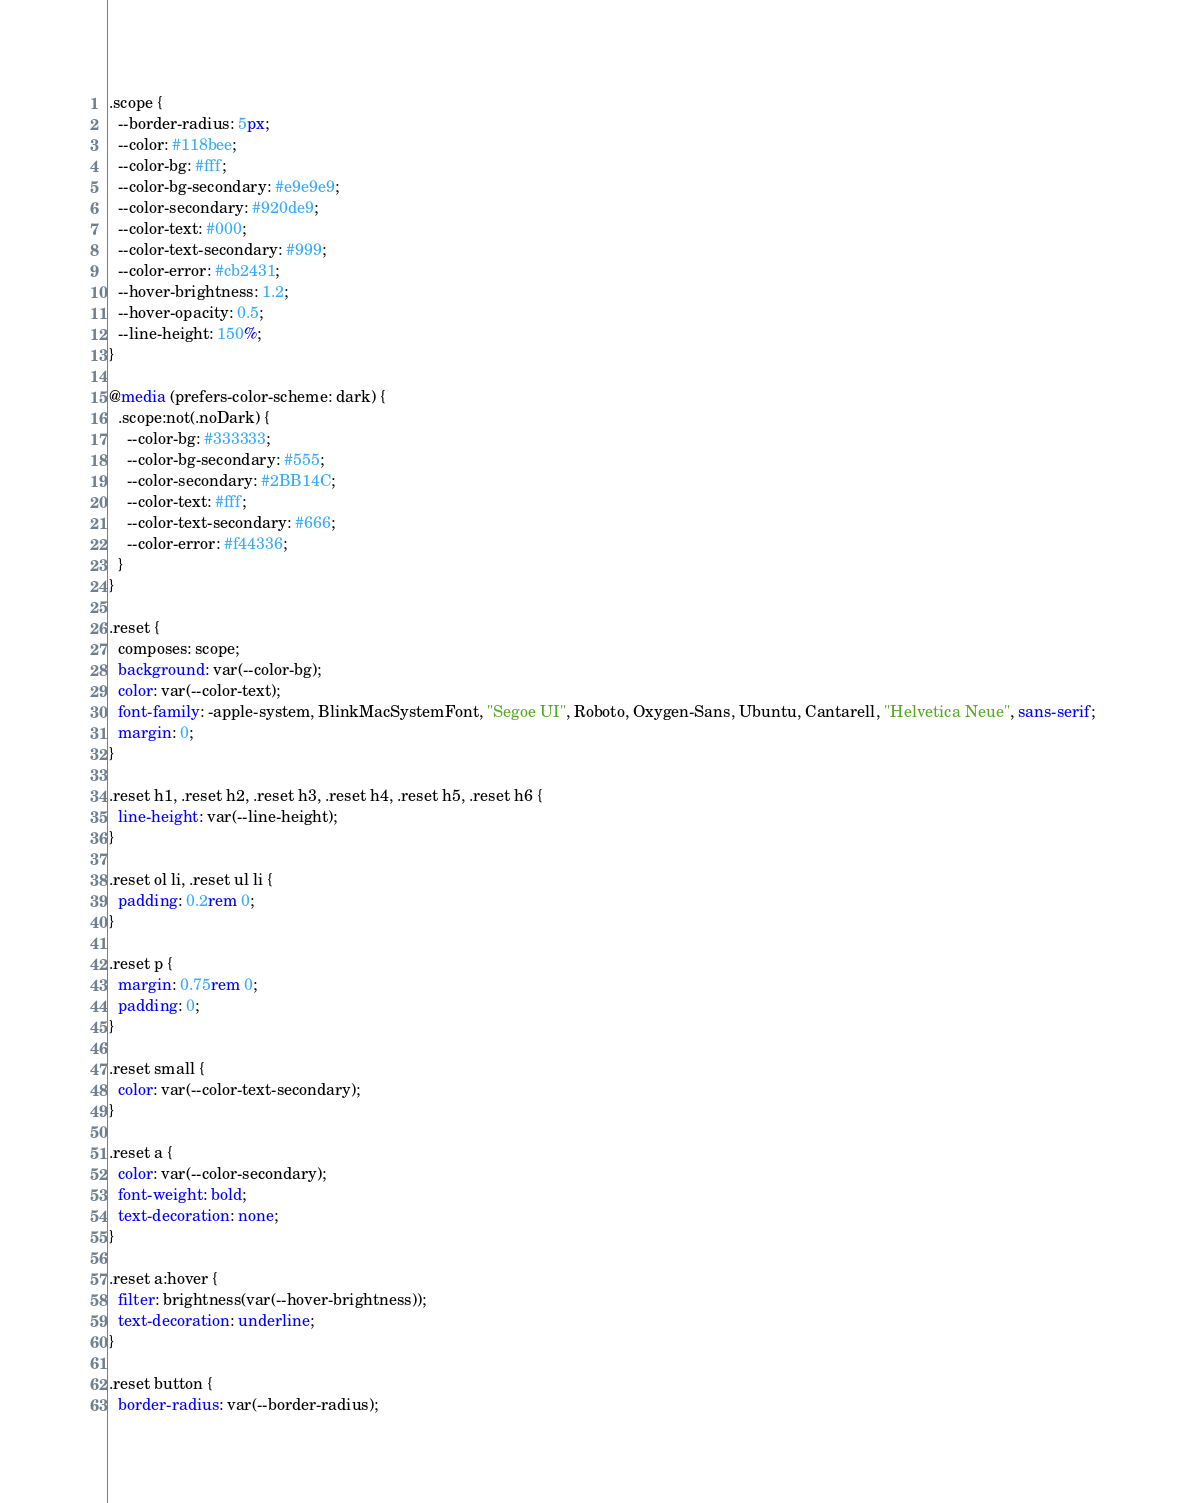Convert code to text. <code><loc_0><loc_0><loc_500><loc_500><_CSS_>.scope {
  --border-radius: 5px;
  --color: #118bee;
  --color-bg: #fff;
  --color-bg-secondary: #e9e9e9;
  --color-secondary: #920de9;
  --color-text: #000;
  --color-text-secondary: #999;
  --color-error: #cb2431;
  --hover-brightness: 1.2;
  --hover-opacity: 0.5;
  --line-height: 150%;
}

@media (prefers-color-scheme: dark) {
  .scope:not(.noDark) {
    --color-bg: #333333;
    --color-bg-secondary: #555;
    --color-secondary: #2BB14C;
    --color-text: #fff;
    --color-text-secondary: #666;
    --color-error: #f44336;
  }
}

.reset {
  composes: scope;
  background: var(--color-bg);
  color: var(--color-text);
  font-family: -apple-system, BlinkMacSystemFont, "Segoe UI", Roboto, Oxygen-Sans, Ubuntu, Cantarell, "Helvetica Neue", sans-serif;
  margin: 0;
}

.reset h1, .reset h2, .reset h3, .reset h4, .reset h5, .reset h6 {
  line-height: var(--line-height);
}

.reset ol li, .reset ul li {
  padding: 0.2rem 0;
}

.reset p {
  margin: 0.75rem 0;
  padding: 0;
}

.reset small {
  color: var(--color-text-secondary);
}

.reset a {
  color: var(--color-secondary);
  font-weight: bold;
  text-decoration: none;
}

.reset a:hover {
  filter: brightness(var(--hover-brightness));
  text-decoration: underline;
}

.reset button {
  border-radius: var(--border-radius);</code> 